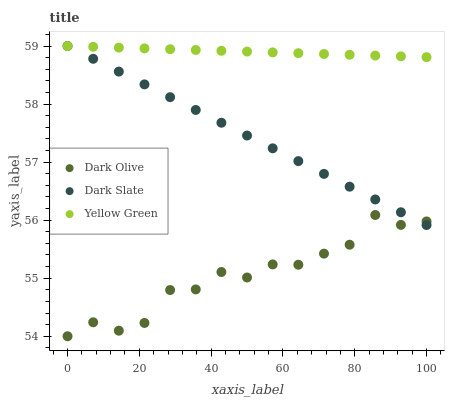Does Dark Olive have the minimum area under the curve?
Answer yes or no. Yes. Does Yellow Green have the maximum area under the curve?
Answer yes or no. Yes. Does Yellow Green have the minimum area under the curve?
Answer yes or no. No. Does Dark Olive have the maximum area under the curve?
Answer yes or no. No. Is Yellow Green the smoothest?
Answer yes or no. Yes. Is Dark Olive the roughest?
Answer yes or no. Yes. Is Dark Olive the smoothest?
Answer yes or no. No. Is Yellow Green the roughest?
Answer yes or no. No. Does Dark Olive have the lowest value?
Answer yes or no. Yes. Does Yellow Green have the lowest value?
Answer yes or no. No. Does Yellow Green have the highest value?
Answer yes or no. Yes. Does Dark Olive have the highest value?
Answer yes or no. No. Is Dark Olive less than Yellow Green?
Answer yes or no. Yes. Is Yellow Green greater than Dark Olive?
Answer yes or no. Yes. Does Dark Slate intersect Dark Olive?
Answer yes or no. Yes. Is Dark Slate less than Dark Olive?
Answer yes or no. No. Is Dark Slate greater than Dark Olive?
Answer yes or no. No. Does Dark Olive intersect Yellow Green?
Answer yes or no. No. 